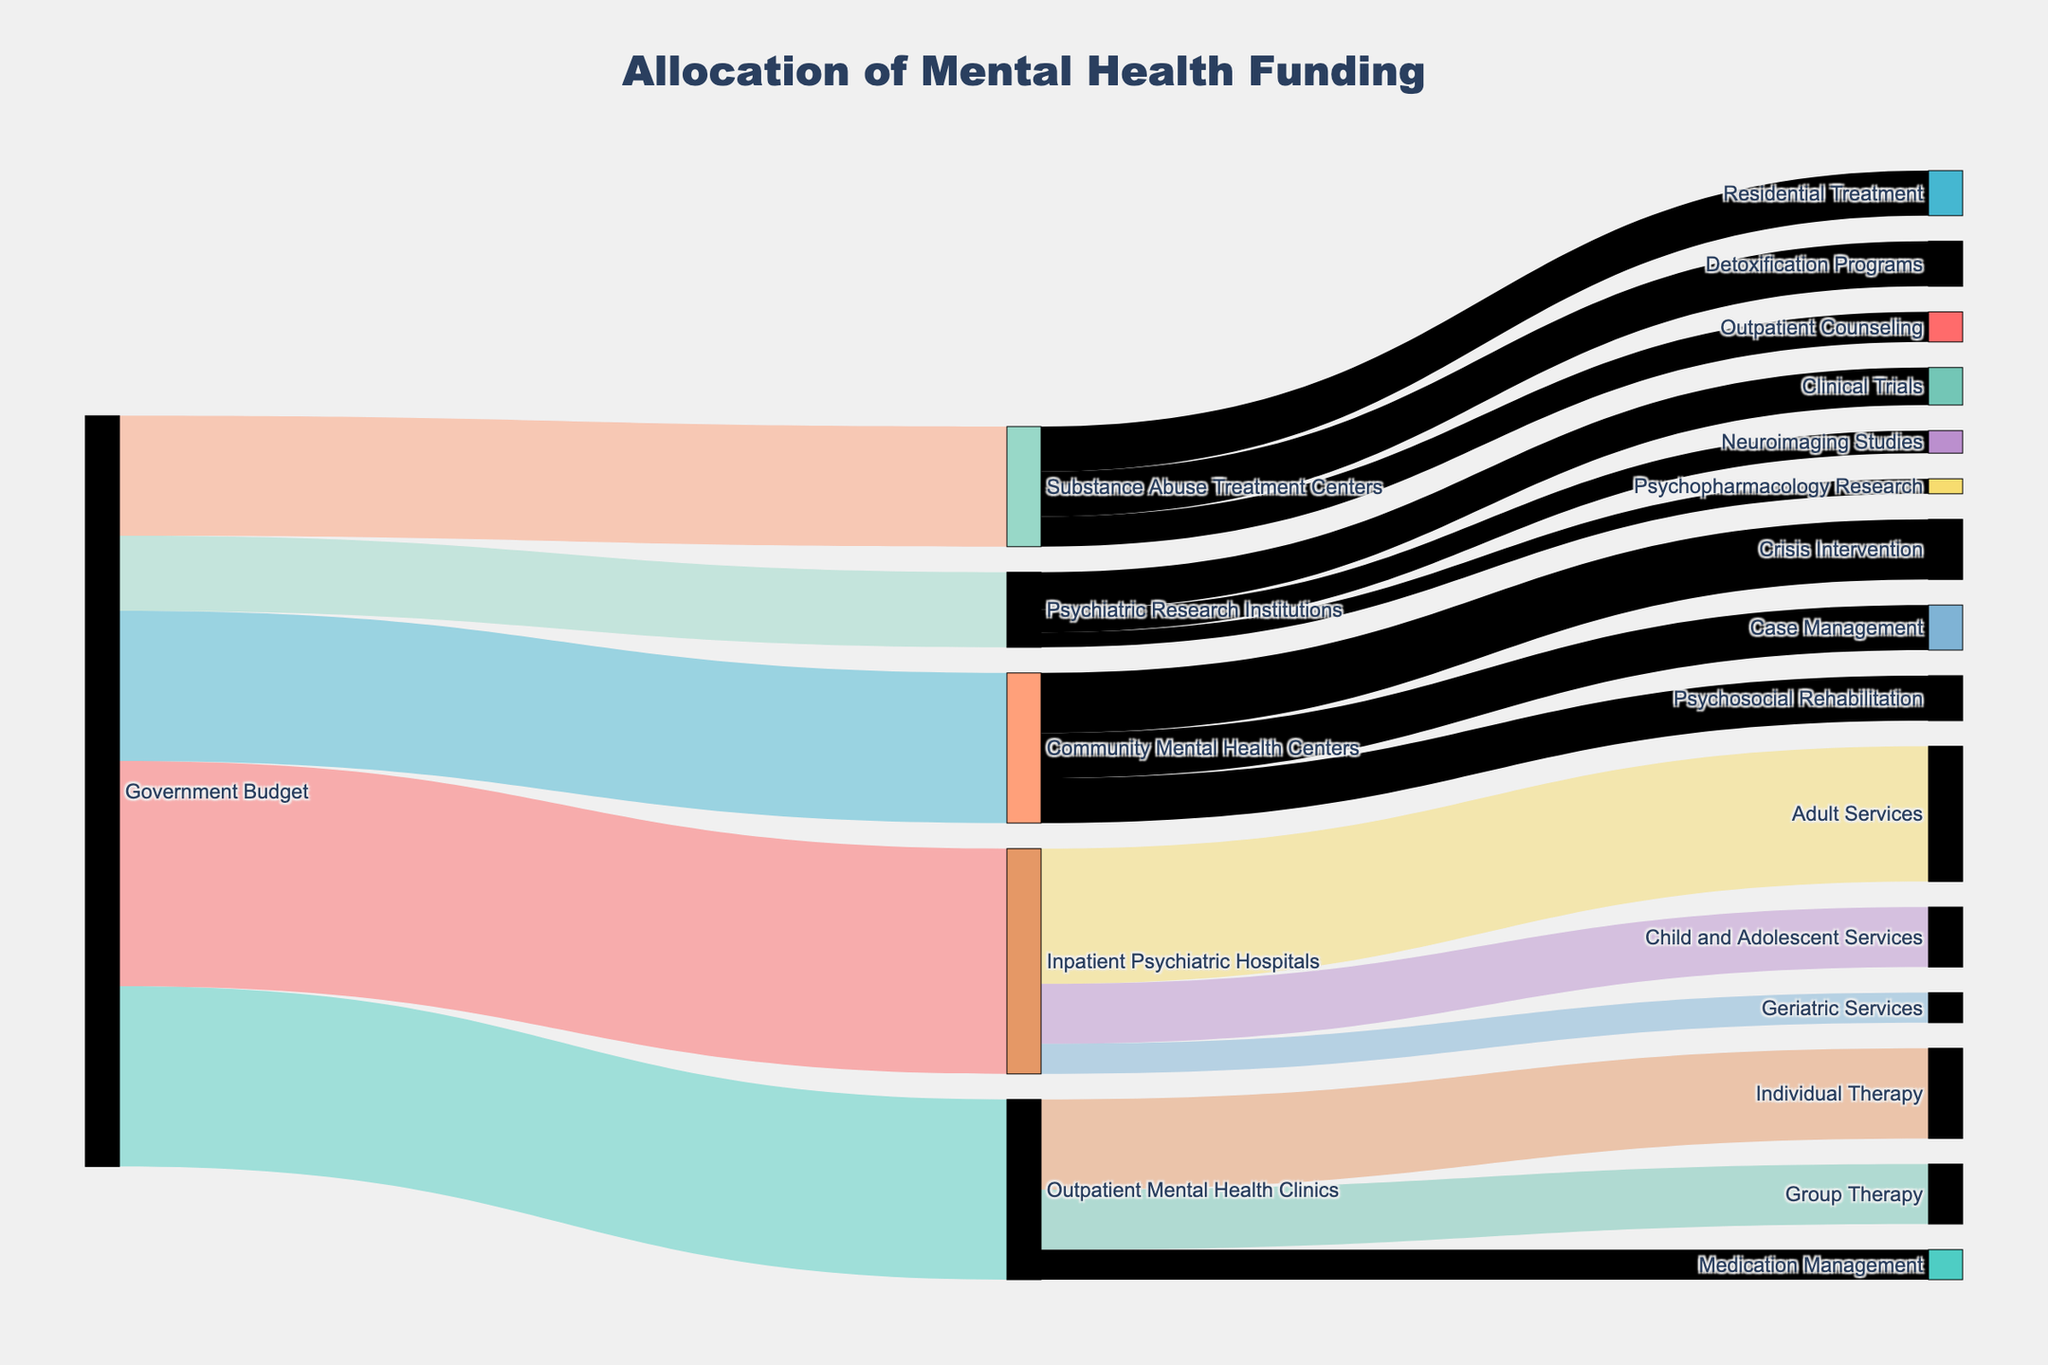what is the title of the figure? The title of the plot is typically located at the top center of the figure, often in a larger and bold font. In this case, it reads "Allocation of Mental Health Funding".
Answer: Allocation of Mental Health Funding How much funding is allocated to Inpatient Psychiatric Hospitals from the Government Budget? To find this, look for the link connecting "Government Budget" to "Inpatient Psychiatric Hospitals" and check the value associated with it.
Answer: 150 Which category receives the least amount of funding from the Government Budget? Compare the values of all connections originating from "Government Budget" and identify the smallest value. Here, "Psychiatric Research Institutions" receives the least funding.
Answer: Psychiatric Research Institutions What is the total funding allocated to Community Mental Health Centers and Substance Abuse Treatment Centers combined? Sum the values of the links from "Government Budget" to "Community Mental Health Centers" and "Government Budget" to "Substance Abuse Treatment Centers". Here, 100 (Community Mental Health Centers) + 80 (Substance Abuse Treatment Centers) = 180.
Answer: 180 Which type of service receives the highest funding within Outpatient Mental Health Clinics? Within "Outpatient Mental Health Clinics", compare the values for "Individual Therapy", "Group Therapy", and "Medication Management". "Individual Therapy" has the highest funding at 60.
Answer: Individual Therapy How much total funding is dedicated to Adult Services across all categories? Identify and sum all links going into "Adult Services". Here, it's only from "Inpatient Psychiatric Hospitals" to "Adult Services", which equals 90.
Answer: 90 Which category between "Detoxification Programs" and "Residential Treatment" within Substance Abuse Treatment Centers receives more funding? Compare the values of the connections to "Detoxification Programs" and "Residential Treatment". Both are at the same level of funding, which is 30 each.
Answer: Both receive equal funding What is the difference in funding between Individual Therapy and Psychosocial Rehabilitation? Find their respective funding values and subtract the smaller from the larger. "Individual Therapy" is 60 and "Psychosocial Rehabilitation" is 30, hence the difference is 60 - 30 = 30.
Answer: 30 How much funding does Psychiatric Research Institutions allocate to Clinical Trials and Neuroimaging Studies combined? Sum the values of the links from "Psychiatric Research Institutions" to "Clinical Trials" and "Neuroimaging Studies". Here, 25 (Clinical Trials) + 15 (Neuroimaging Studies) = 40.
Answer: 40 